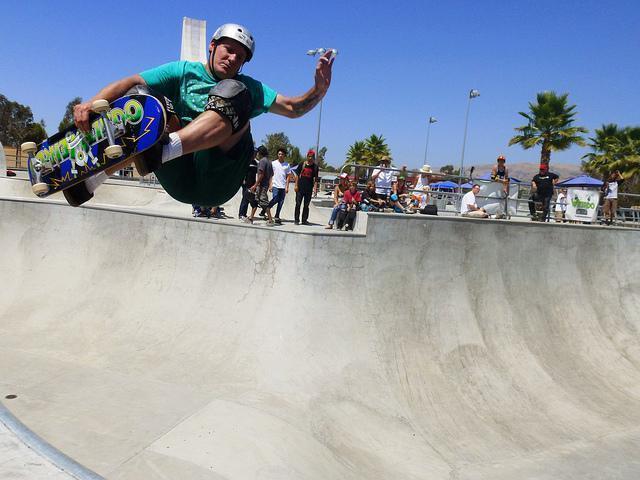What is this skateboarding feature?
Select the accurate response from the four choices given to answer the question.
Options: Funbox, bowl, rail, half-pipe. Half-pipe. 